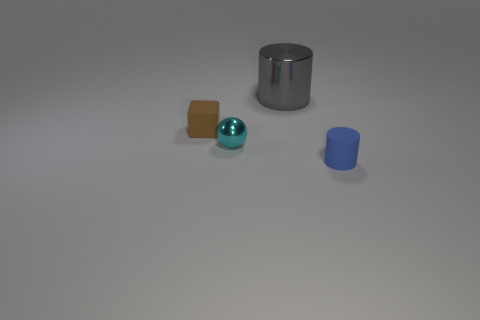Subtract 1 cylinders. How many cylinders are left? 1 Add 2 gray metal cylinders. How many objects exist? 6 Subtract all blue cylinders. How many cylinders are left? 1 Subtract all cyan cylinders. Subtract all yellow balls. How many cylinders are left? 2 Subtract 0 purple cylinders. How many objects are left? 4 Subtract all cyan cylinders. How many cyan cubes are left? 0 Subtract all tiny metal balls. Subtract all tiny spheres. How many objects are left? 2 Add 3 gray shiny cylinders. How many gray shiny cylinders are left? 4 Add 4 blue cylinders. How many blue cylinders exist? 5 